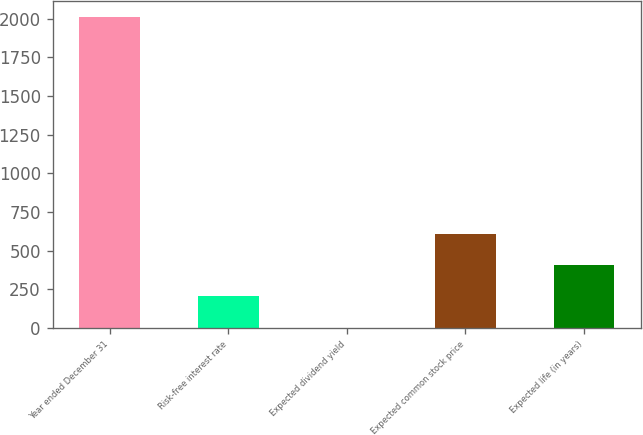Convert chart to OTSL. <chart><loc_0><loc_0><loc_500><loc_500><bar_chart><fcel>Year ended December 31<fcel>Risk-free interest rate<fcel>Expected dividend yield<fcel>Expected common stock price<fcel>Expected life (in years)<nl><fcel>2011<fcel>203.08<fcel>2.2<fcel>604.84<fcel>403.96<nl></chart> 